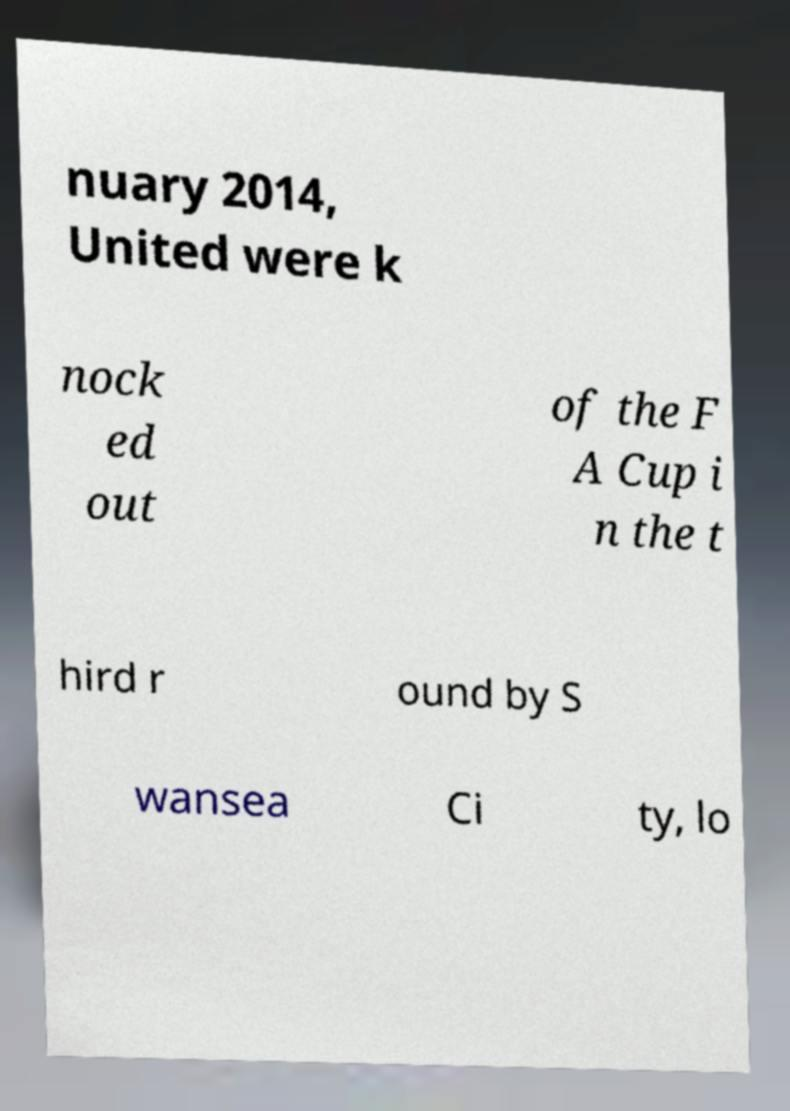Can you read and provide the text displayed in the image?This photo seems to have some interesting text. Can you extract and type it out for me? nuary 2014, United were k nock ed out of the F A Cup i n the t hird r ound by S wansea Ci ty, lo 